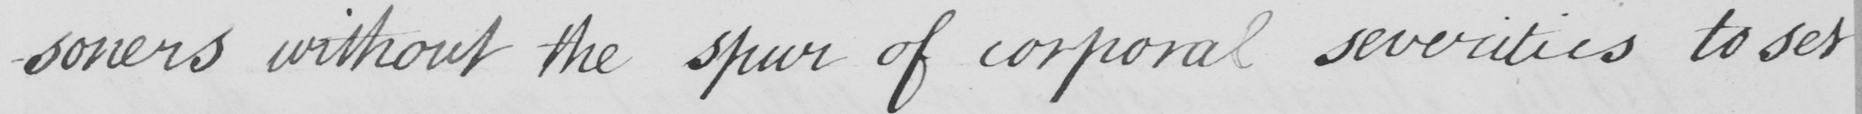What text is written in this handwritten line? -soners without the spur of corporal severities to set 